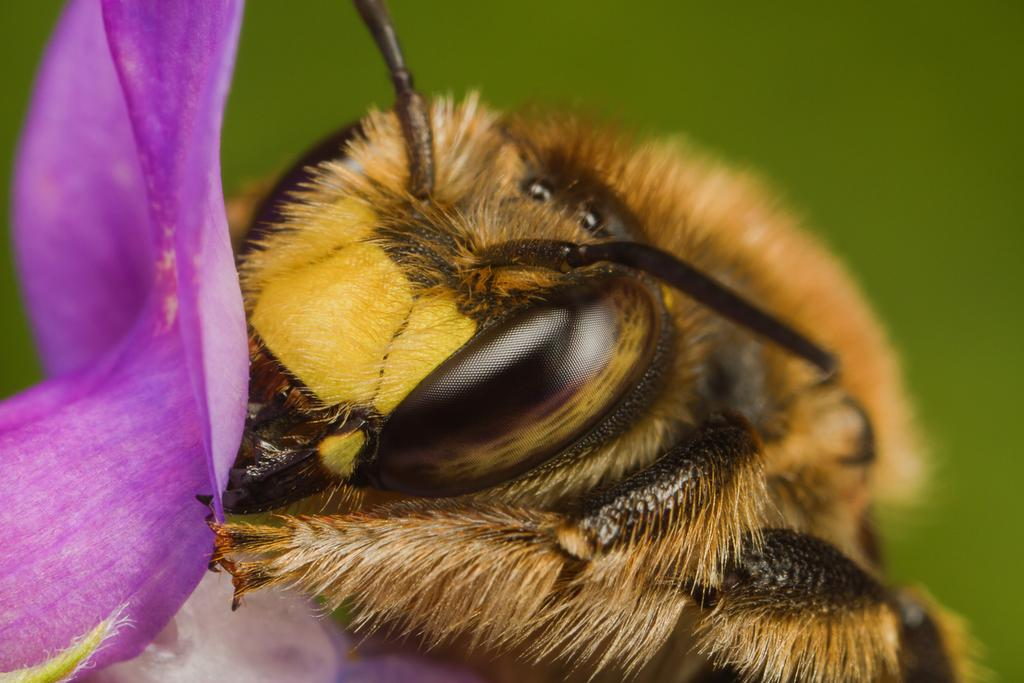What type of animal can be seen in the image? There is a bird in the image. What other living organism is present in the image? There is a flower in the image. Can you describe the background of the image? The background of the image is blurred. What type of cheese is being taught by the bird in the image? There is no cheese or teaching activity present in the image. The bird is simply perched near the flower, and there is no indication of any educational activity taking place. 